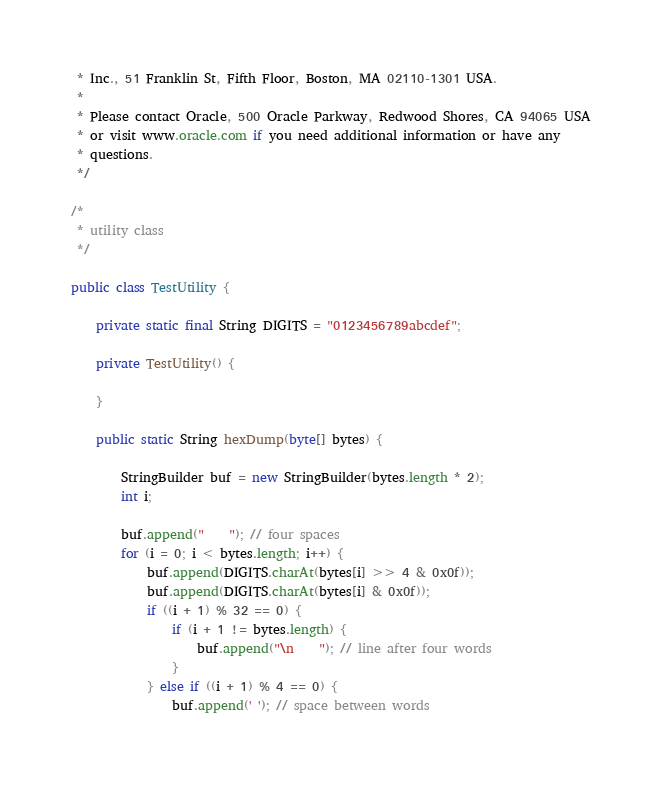<code> <loc_0><loc_0><loc_500><loc_500><_Java_> * Inc., 51 Franklin St, Fifth Floor, Boston, MA 02110-1301 USA.
 *
 * Please contact Oracle, 500 Oracle Parkway, Redwood Shores, CA 94065 USA
 * or visit www.oracle.com if you need additional information or have any
 * questions.
 */

/*
 * utility class
 */

public class TestUtility {

    private static final String DIGITS = "0123456789abcdef";

    private TestUtility() {

    }

    public static String hexDump(byte[] bytes) {

        StringBuilder buf = new StringBuilder(bytes.length * 2);
        int i;

        buf.append("    "); // four spaces
        for (i = 0; i < bytes.length; i++) {
            buf.append(DIGITS.charAt(bytes[i] >> 4 & 0x0f));
            buf.append(DIGITS.charAt(bytes[i] & 0x0f));
            if ((i + 1) % 32 == 0) {
                if (i + 1 != bytes.length) {
                    buf.append("\n    "); // line after four words
                }
            } else if ((i + 1) % 4 == 0) {
                buf.append(' '); // space between words</code> 